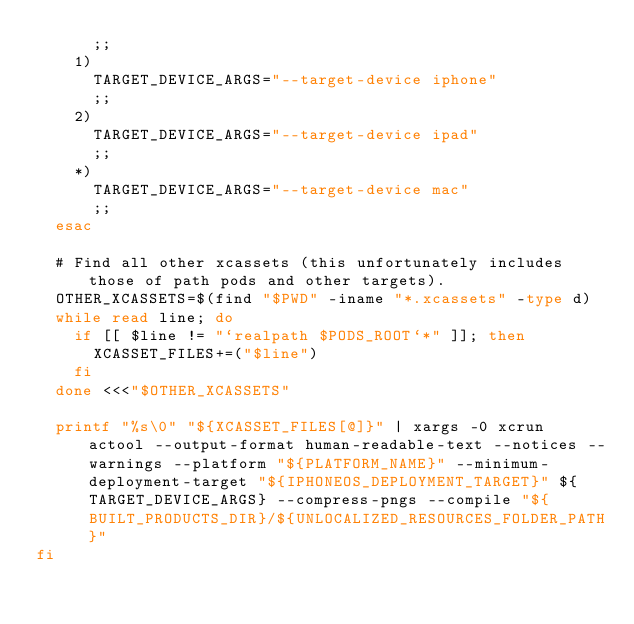Convert code to text. <code><loc_0><loc_0><loc_500><loc_500><_Bash_>      ;;
    1)
      TARGET_DEVICE_ARGS="--target-device iphone"
      ;;
    2)
      TARGET_DEVICE_ARGS="--target-device ipad"
      ;;
    *)
      TARGET_DEVICE_ARGS="--target-device mac"
      ;;
  esac

  # Find all other xcassets (this unfortunately includes those of path pods and other targets).
  OTHER_XCASSETS=$(find "$PWD" -iname "*.xcassets" -type d)
  while read line; do
    if [[ $line != "`realpath $PODS_ROOT`*" ]]; then
      XCASSET_FILES+=("$line")
    fi
  done <<<"$OTHER_XCASSETS"

  printf "%s\0" "${XCASSET_FILES[@]}" | xargs -0 xcrun actool --output-format human-readable-text --notices --warnings --platform "${PLATFORM_NAME}" --minimum-deployment-target "${IPHONEOS_DEPLOYMENT_TARGET}" ${TARGET_DEVICE_ARGS} --compress-pngs --compile "${BUILT_PRODUCTS_DIR}/${UNLOCALIZED_RESOURCES_FOLDER_PATH}"
fi
</code> 